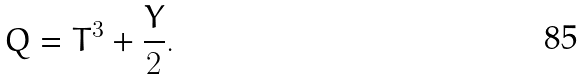Convert formula to latex. <formula><loc_0><loc_0><loc_500><loc_500>Q = T ^ { 3 } + \frac { Y } 2 .</formula> 